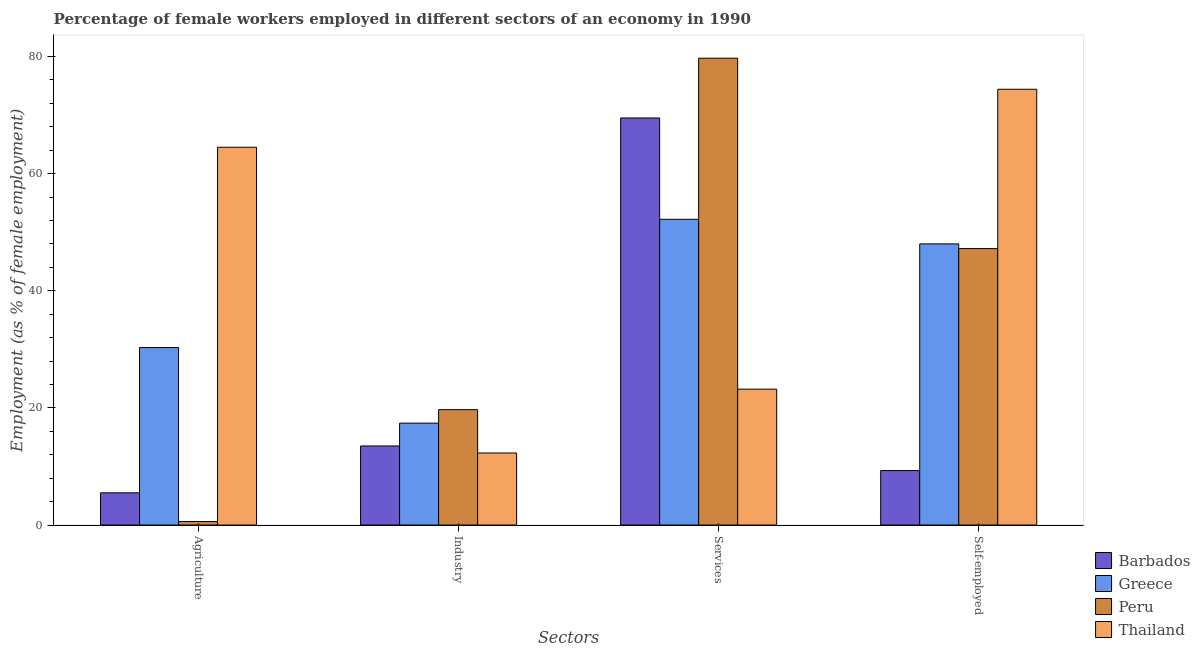Are the number of bars per tick equal to the number of legend labels?
Ensure brevity in your answer.  Yes. Are the number of bars on each tick of the X-axis equal?
Make the answer very short. Yes. How many bars are there on the 3rd tick from the left?
Offer a terse response. 4. How many bars are there on the 3rd tick from the right?
Keep it short and to the point. 4. What is the label of the 3rd group of bars from the left?
Offer a terse response. Services. What is the percentage of female workers in services in Thailand?
Your response must be concise. 23.2. Across all countries, what is the maximum percentage of female workers in industry?
Provide a short and direct response. 19.7. Across all countries, what is the minimum percentage of female workers in industry?
Give a very brief answer. 12.3. In which country was the percentage of self employed female workers maximum?
Make the answer very short. Thailand. In which country was the percentage of self employed female workers minimum?
Ensure brevity in your answer.  Barbados. What is the total percentage of female workers in services in the graph?
Your answer should be very brief. 224.6. What is the difference between the percentage of female workers in agriculture in Thailand and that in Peru?
Provide a short and direct response. 63.9. What is the difference between the percentage of self employed female workers in Peru and the percentage of female workers in agriculture in Barbados?
Provide a short and direct response. 41.7. What is the average percentage of female workers in agriculture per country?
Ensure brevity in your answer.  25.22. In how many countries, is the percentage of female workers in industry greater than 68 %?
Keep it short and to the point. 0. What is the ratio of the percentage of female workers in services in Barbados to that in Greece?
Give a very brief answer. 1.33. Is the difference between the percentage of female workers in agriculture in Thailand and Peru greater than the difference between the percentage of female workers in services in Thailand and Peru?
Your response must be concise. Yes. What is the difference between the highest and the second highest percentage of self employed female workers?
Ensure brevity in your answer.  26.4. What is the difference between the highest and the lowest percentage of female workers in services?
Give a very brief answer. 56.5. In how many countries, is the percentage of female workers in agriculture greater than the average percentage of female workers in agriculture taken over all countries?
Ensure brevity in your answer.  2. Is it the case that in every country, the sum of the percentage of female workers in services and percentage of self employed female workers is greater than the sum of percentage of female workers in industry and percentage of female workers in agriculture?
Your response must be concise. No. What does the 2nd bar from the right in Agriculture represents?
Offer a terse response. Peru. How many bars are there?
Keep it short and to the point. 16. Are all the bars in the graph horizontal?
Your response must be concise. No. What is the difference between two consecutive major ticks on the Y-axis?
Keep it short and to the point. 20. Does the graph contain grids?
Your answer should be very brief. No. Where does the legend appear in the graph?
Provide a succinct answer. Bottom right. How are the legend labels stacked?
Offer a very short reply. Vertical. What is the title of the graph?
Your response must be concise. Percentage of female workers employed in different sectors of an economy in 1990. What is the label or title of the X-axis?
Ensure brevity in your answer.  Sectors. What is the label or title of the Y-axis?
Your answer should be very brief. Employment (as % of female employment). What is the Employment (as % of female employment) in Barbados in Agriculture?
Your answer should be very brief. 5.5. What is the Employment (as % of female employment) of Greece in Agriculture?
Give a very brief answer. 30.3. What is the Employment (as % of female employment) of Peru in Agriculture?
Provide a succinct answer. 0.6. What is the Employment (as % of female employment) of Thailand in Agriculture?
Keep it short and to the point. 64.5. What is the Employment (as % of female employment) in Greece in Industry?
Offer a terse response. 17.4. What is the Employment (as % of female employment) of Peru in Industry?
Provide a succinct answer. 19.7. What is the Employment (as % of female employment) of Thailand in Industry?
Your answer should be compact. 12.3. What is the Employment (as % of female employment) in Barbados in Services?
Offer a terse response. 69.5. What is the Employment (as % of female employment) in Greece in Services?
Keep it short and to the point. 52.2. What is the Employment (as % of female employment) of Peru in Services?
Keep it short and to the point. 79.7. What is the Employment (as % of female employment) of Thailand in Services?
Offer a very short reply. 23.2. What is the Employment (as % of female employment) of Barbados in Self-employed?
Your answer should be very brief. 9.3. What is the Employment (as % of female employment) of Peru in Self-employed?
Your answer should be very brief. 47.2. What is the Employment (as % of female employment) in Thailand in Self-employed?
Provide a succinct answer. 74.4. Across all Sectors, what is the maximum Employment (as % of female employment) in Barbados?
Provide a succinct answer. 69.5. Across all Sectors, what is the maximum Employment (as % of female employment) of Greece?
Keep it short and to the point. 52.2. Across all Sectors, what is the maximum Employment (as % of female employment) of Peru?
Provide a short and direct response. 79.7. Across all Sectors, what is the maximum Employment (as % of female employment) in Thailand?
Offer a terse response. 74.4. Across all Sectors, what is the minimum Employment (as % of female employment) of Barbados?
Your answer should be compact. 5.5. Across all Sectors, what is the minimum Employment (as % of female employment) of Greece?
Your answer should be very brief. 17.4. Across all Sectors, what is the minimum Employment (as % of female employment) of Peru?
Keep it short and to the point. 0.6. Across all Sectors, what is the minimum Employment (as % of female employment) of Thailand?
Your response must be concise. 12.3. What is the total Employment (as % of female employment) in Barbados in the graph?
Your response must be concise. 97.8. What is the total Employment (as % of female employment) in Greece in the graph?
Make the answer very short. 147.9. What is the total Employment (as % of female employment) in Peru in the graph?
Your response must be concise. 147.2. What is the total Employment (as % of female employment) of Thailand in the graph?
Ensure brevity in your answer.  174.4. What is the difference between the Employment (as % of female employment) in Barbados in Agriculture and that in Industry?
Offer a terse response. -8. What is the difference between the Employment (as % of female employment) in Greece in Agriculture and that in Industry?
Offer a terse response. 12.9. What is the difference between the Employment (as % of female employment) of Peru in Agriculture and that in Industry?
Offer a very short reply. -19.1. What is the difference between the Employment (as % of female employment) of Thailand in Agriculture and that in Industry?
Provide a succinct answer. 52.2. What is the difference between the Employment (as % of female employment) in Barbados in Agriculture and that in Services?
Offer a terse response. -64. What is the difference between the Employment (as % of female employment) of Greece in Agriculture and that in Services?
Provide a succinct answer. -21.9. What is the difference between the Employment (as % of female employment) of Peru in Agriculture and that in Services?
Ensure brevity in your answer.  -79.1. What is the difference between the Employment (as % of female employment) of Thailand in Agriculture and that in Services?
Keep it short and to the point. 41.3. What is the difference between the Employment (as % of female employment) in Barbados in Agriculture and that in Self-employed?
Give a very brief answer. -3.8. What is the difference between the Employment (as % of female employment) of Greece in Agriculture and that in Self-employed?
Keep it short and to the point. -17.7. What is the difference between the Employment (as % of female employment) of Peru in Agriculture and that in Self-employed?
Make the answer very short. -46.6. What is the difference between the Employment (as % of female employment) of Thailand in Agriculture and that in Self-employed?
Your answer should be very brief. -9.9. What is the difference between the Employment (as % of female employment) in Barbados in Industry and that in Services?
Ensure brevity in your answer.  -56. What is the difference between the Employment (as % of female employment) of Greece in Industry and that in Services?
Your answer should be very brief. -34.8. What is the difference between the Employment (as % of female employment) of Peru in Industry and that in Services?
Provide a succinct answer. -60. What is the difference between the Employment (as % of female employment) in Barbados in Industry and that in Self-employed?
Offer a terse response. 4.2. What is the difference between the Employment (as % of female employment) of Greece in Industry and that in Self-employed?
Provide a succinct answer. -30.6. What is the difference between the Employment (as % of female employment) in Peru in Industry and that in Self-employed?
Give a very brief answer. -27.5. What is the difference between the Employment (as % of female employment) of Thailand in Industry and that in Self-employed?
Your response must be concise. -62.1. What is the difference between the Employment (as % of female employment) in Barbados in Services and that in Self-employed?
Provide a succinct answer. 60.2. What is the difference between the Employment (as % of female employment) in Greece in Services and that in Self-employed?
Make the answer very short. 4.2. What is the difference between the Employment (as % of female employment) in Peru in Services and that in Self-employed?
Your answer should be compact. 32.5. What is the difference between the Employment (as % of female employment) in Thailand in Services and that in Self-employed?
Offer a terse response. -51.2. What is the difference between the Employment (as % of female employment) of Barbados in Agriculture and the Employment (as % of female employment) of Greece in Industry?
Give a very brief answer. -11.9. What is the difference between the Employment (as % of female employment) in Barbados in Agriculture and the Employment (as % of female employment) in Peru in Industry?
Offer a very short reply. -14.2. What is the difference between the Employment (as % of female employment) of Greece in Agriculture and the Employment (as % of female employment) of Peru in Industry?
Offer a terse response. 10.6. What is the difference between the Employment (as % of female employment) of Barbados in Agriculture and the Employment (as % of female employment) of Greece in Services?
Keep it short and to the point. -46.7. What is the difference between the Employment (as % of female employment) of Barbados in Agriculture and the Employment (as % of female employment) of Peru in Services?
Your answer should be compact. -74.2. What is the difference between the Employment (as % of female employment) in Barbados in Agriculture and the Employment (as % of female employment) in Thailand in Services?
Ensure brevity in your answer.  -17.7. What is the difference between the Employment (as % of female employment) in Greece in Agriculture and the Employment (as % of female employment) in Peru in Services?
Your answer should be compact. -49.4. What is the difference between the Employment (as % of female employment) in Peru in Agriculture and the Employment (as % of female employment) in Thailand in Services?
Provide a succinct answer. -22.6. What is the difference between the Employment (as % of female employment) in Barbados in Agriculture and the Employment (as % of female employment) in Greece in Self-employed?
Offer a terse response. -42.5. What is the difference between the Employment (as % of female employment) in Barbados in Agriculture and the Employment (as % of female employment) in Peru in Self-employed?
Provide a short and direct response. -41.7. What is the difference between the Employment (as % of female employment) of Barbados in Agriculture and the Employment (as % of female employment) of Thailand in Self-employed?
Offer a terse response. -68.9. What is the difference between the Employment (as % of female employment) in Greece in Agriculture and the Employment (as % of female employment) in Peru in Self-employed?
Your answer should be compact. -16.9. What is the difference between the Employment (as % of female employment) of Greece in Agriculture and the Employment (as % of female employment) of Thailand in Self-employed?
Keep it short and to the point. -44.1. What is the difference between the Employment (as % of female employment) of Peru in Agriculture and the Employment (as % of female employment) of Thailand in Self-employed?
Make the answer very short. -73.8. What is the difference between the Employment (as % of female employment) of Barbados in Industry and the Employment (as % of female employment) of Greece in Services?
Offer a terse response. -38.7. What is the difference between the Employment (as % of female employment) of Barbados in Industry and the Employment (as % of female employment) of Peru in Services?
Your answer should be compact. -66.2. What is the difference between the Employment (as % of female employment) in Barbados in Industry and the Employment (as % of female employment) in Thailand in Services?
Give a very brief answer. -9.7. What is the difference between the Employment (as % of female employment) of Greece in Industry and the Employment (as % of female employment) of Peru in Services?
Your response must be concise. -62.3. What is the difference between the Employment (as % of female employment) in Greece in Industry and the Employment (as % of female employment) in Thailand in Services?
Offer a terse response. -5.8. What is the difference between the Employment (as % of female employment) in Barbados in Industry and the Employment (as % of female employment) in Greece in Self-employed?
Keep it short and to the point. -34.5. What is the difference between the Employment (as % of female employment) of Barbados in Industry and the Employment (as % of female employment) of Peru in Self-employed?
Keep it short and to the point. -33.7. What is the difference between the Employment (as % of female employment) of Barbados in Industry and the Employment (as % of female employment) of Thailand in Self-employed?
Offer a very short reply. -60.9. What is the difference between the Employment (as % of female employment) of Greece in Industry and the Employment (as % of female employment) of Peru in Self-employed?
Offer a very short reply. -29.8. What is the difference between the Employment (as % of female employment) in Greece in Industry and the Employment (as % of female employment) in Thailand in Self-employed?
Provide a succinct answer. -57. What is the difference between the Employment (as % of female employment) in Peru in Industry and the Employment (as % of female employment) in Thailand in Self-employed?
Offer a terse response. -54.7. What is the difference between the Employment (as % of female employment) of Barbados in Services and the Employment (as % of female employment) of Greece in Self-employed?
Provide a succinct answer. 21.5. What is the difference between the Employment (as % of female employment) of Barbados in Services and the Employment (as % of female employment) of Peru in Self-employed?
Your response must be concise. 22.3. What is the difference between the Employment (as % of female employment) in Greece in Services and the Employment (as % of female employment) in Thailand in Self-employed?
Keep it short and to the point. -22.2. What is the difference between the Employment (as % of female employment) of Peru in Services and the Employment (as % of female employment) of Thailand in Self-employed?
Your response must be concise. 5.3. What is the average Employment (as % of female employment) in Barbados per Sectors?
Offer a terse response. 24.45. What is the average Employment (as % of female employment) of Greece per Sectors?
Make the answer very short. 36.98. What is the average Employment (as % of female employment) in Peru per Sectors?
Your response must be concise. 36.8. What is the average Employment (as % of female employment) of Thailand per Sectors?
Keep it short and to the point. 43.6. What is the difference between the Employment (as % of female employment) in Barbados and Employment (as % of female employment) in Greece in Agriculture?
Your response must be concise. -24.8. What is the difference between the Employment (as % of female employment) in Barbados and Employment (as % of female employment) in Thailand in Agriculture?
Your answer should be compact. -59. What is the difference between the Employment (as % of female employment) of Greece and Employment (as % of female employment) of Peru in Agriculture?
Offer a terse response. 29.7. What is the difference between the Employment (as % of female employment) in Greece and Employment (as % of female employment) in Thailand in Agriculture?
Offer a very short reply. -34.2. What is the difference between the Employment (as % of female employment) of Peru and Employment (as % of female employment) of Thailand in Agriculture?
Offer a terse response. -63.9. What is the difference between the Employment (as % of female employment) of Barbados and Employment (as % of female employment) of Thailand in Industry?
Your response must be concise. 1.2. What is the difference between the Employment (as % of female employment) of Peru and Employment (as % of female employment) of Thailand in Industry?
Give a very brief answer. 7.4. What is the difference between the Employment (as % of female employment) of Barbados and Employment (as % of female employment) of Peru in Services?
Make the answer very short. -10.2. What is the difference between the Employment (as % of female employment) in Barbados and Employment (as % of female employment) in Thailand in Services?
Your answer should be very brief. 46.3. What is the difference between the Employment (as % of female employment) in Greece and Employment (as % of female employment) in Peru in Services?
Offer a terse response. -27.5. What is the difference between the Employment (as % of female employment) in Peru and Employment (as % of female employment) in Thailand in Services?
Your response must be concise. 56.5. What is the difference between the Employment (as % of female employment) in Barbados and Employment (as % of female employment) in Greece in Self-employed?
Offer a very short reply. -38.7. What is the difference between the Employment (as % of female employment) of Barbados and Employment (as % of female employment) of Peru in Self-employed?
Provide a succinct answer. -37.9. What is the difference between the Employment (as % of female employment) in Barbados and Employment (as % of female employment) in Thailand in Self-employed?
Offer a very short reply. -65.1. What is the difference between the Employment (as % of female employment) of Greece and Employment (as % of female employment) of Peru in Self-employed?
Give a very brief answer. 0.8. What is the difference between the Employment (as % of female employment) of Greece and Employment (as % of female employment) of Thailand in Self-employed?
Offer a terse response. -26.4. What is the difference between the Employment (as % of female employment) of Peru and Employment (as % of female employment) of Thailand in Self-employed?
Your answer should be very brief. -27.2. What is the ratio of the Employment (as % of female employment) of Barbados in Agriculture to that in Industry?
Make the answer very short. 0.41. What is the ratio of the Employment (as % of female employment) of Greece in Agriculture to that in Industry?
Your response must be concise. 1.74. What is the ratio of the Employment (as % of female employment) of Peru in Agriculture to that in Industry?
Keep it short and to the point. 0.03. What is the ratio of the Employment (as % of female employment) in Thailand in Agriculture to that in Industry?
Give a very brief answer. 5.24. What is the ratio of the Employment (as % of female employment) of Barbados in Agriculture to that in Services?
Provide a short and direct response. 0.08. What is the ratio of the Employment (as % of female employment) of Greece in Agriculture to that in Services?
Provide a succinct answer. 0.58. What is the ratio of the Employment (as % of female employment) in Peru in Agriculture to that in Services?
Offer a terse response. 0.01. What is the ratio of the Employment (as % of female employment) of Thailand in Agriculture to that in Services?
Offer a very short reply. 2.78. What is the ratio of the Employment (as % of female employment) in Barbados in Agriculture to that in Self-employed?
Provide a succinct answer. 0.59. What is the ratio of the Employment (as % of female employment) in Greece in Agriculture to that in Self-employed?
Offer a terse response. 0.63. What is the ratio of the Employment (as % of female employment) in Peru in Agriculture to that in Self-employed?
Your response must be concise. 0.01. What is the ratio of the Employment (as % of female employment) of Thailand in Agriculture to that in Self-employed?
Keep it short and to the point. 0.87. What is the ratio of the Employment (as % of female employment) in Barbados in Industry to that in Services?
Keep it short and to the point. 0.19. What is the ratio of the Employment (as % of female employment) in Greece in Industry to that in Services?
Your response must be concise. 0.33. What is the ratio of the Employment (as % of female employment) in Peru in Industry to that in Services?
Make the answer very short. 0.25. What is the ratio of the Employment (as % of female employment) of Thailand in Industry to that in Services?
Make the answer very short. 0.53. What is the ratio of the Employment (as % of female employment) in Barbados in Industry to that in Self-employed?
Offer a very short reply. 1.45. What is the ratio of the Employment (as % of female employment) of Greece in Industry to that in Self-employed?
Give a very brief answer. 0.36. What is the ratio of the Employment (as % of female employment) in Peru in Industry to that in Self-employed?
Your answer should be very brief. 0.42. What is the ratio of the Employment (as % of female employment) in Thailand in Industry to that in Self-employed?
Offer a very short reply. 0.17. What is the ratio of the Employment (as % of female employment) in Barbados in Services to that in Self-employed?
Give a very brief answer. 7.47. What is the ratio of the Employment (as % of female employment) in Greece in Services to that in Self-employed?
Ensure brevity in your answer.  1.09. What is the ratio of the Employment (as % of female employment) of Peru in Services to that in Self-employed?
Your answer should be compact. 1.69. What is the ratio of the Employment (as % of female employment) of Thailand in Services to that in Self-employed?
Keep it short and to the point. 0.31. What is the difference between the highest and the second highest Employment (as % of female employment) in Barbados?
Offer a terse response. 56. What is the difference between the highest and the second highest Employment (as % of female employment) in Peru?
Provide a succinct answer. 32.5. What is the difference between the highest and the second highest Employment (as % of female employment) in Thailand?
Ensure brevity in your answer.  9.9. What is the difference between the highest and the lowest Employment (as % of female employment) in Greece?
Your response must be concise. 34.8. What is the difference between the highest and the lowest Employment (as % of female employment) in Peru?
Ensure brevity in your answer.  79.1. What is the difference between the highest and the lowest Employment (as % of female employment) of Thailand?
Give a very brief answer. 62.1. 